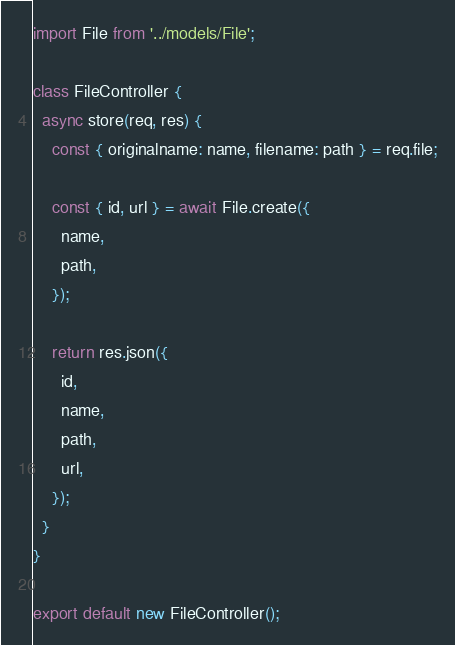Convert code to text. <code><loc_0><loc_0><loc_500><loc_500><_JavaScript_>import File from '../models/File';

class FileController {
  async store(req, res) {
    const { originalname: name, filename: path } = req.file;

    const { id, url } = await File.create({
      name,
      path,
    });

    return res.json({
      id,
      name,
      path,
      url,
    });
  }
}

export default new FileController();
</code> 